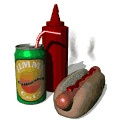Describe the objects in this image and their specific colors. I can see hot dog in white, gray, and maroon tones and bottle in white, maroon, black, and brown tones in this image. 